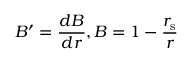<formula> <loc_0><loc_0><loc_500><loc_500>B ^ { \prime } = { \frac { d B } { d r } } , B = 1 - { \frac { r _ { s } } { r } }</formula> 